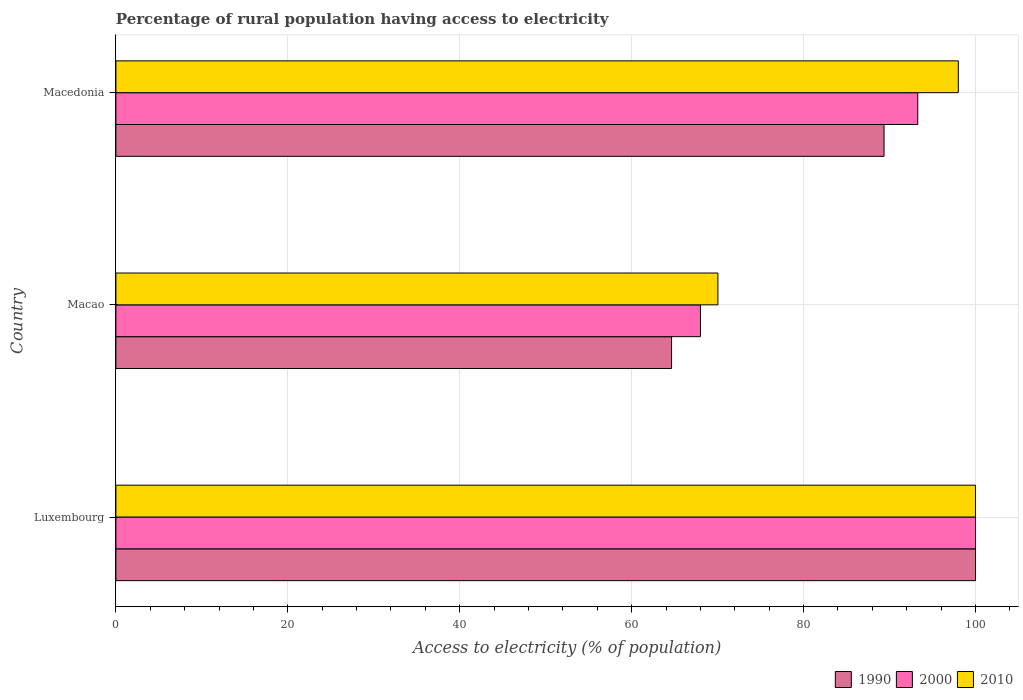How many groups of bars are there?
Make the answer very short. 3. Are the number of bars on each tick of the Y-axis equal?
Offer a very short reply. Yes. How many bars are there on the 1st tick from the top?
Your answer should be very brief. 3. How many bars are there on the 2nd tick from the bottom?
Make the answer very short. 3. What is the label of the 3rd group of bars from the top?
Make the answer very short. Luxembourg. What is the percentage of rural population having access to electricity in 1990 in Luxembourg?
Your response must be concise. 100. Across all countries, what is the maximum percentage of rural population having access to electricity in 1990?
Make the answer very short. 100. Across all countries, what is the minimum percentage of rural population having access to electricity in 1990?
Your answer should be very brief. 64.64. In which country was the percentage of rural population having access to electricity in 2000 maximum?
Keep it short and to the point. Luxembourg. In which country was the percentage of rural population having access to electricity in 2000 minimum?
Your response must be concise. Macao. What is the total percentage of rural population having access to electricity in 2010 in the graph?
Give a very brief answer. 268.03. What is the difference between the percentage of rural population having access to electricity in 1990 in Macao and that in Macedonia?
Your response must be concise. -24.72. What is the difference between the percentage of rural population having access to electricity in 2000 in Macao and the percentage of rural population having access to electricity in 1990 in Luxembourg?
Your answer should be compact. -32. What is the average percentage of rural population having access to electricity in 1990 per country?
Give a very brief answer. 84.67. What is the difference between the percentage of rural population having access to electricity in 1990 and percentage of rural population having access to electricity in 2010 in Macao?
Your answer should be very brief. -5.39. In how many countries, is the percentage of rural population having access to electricity in 2010 greater than 68 %?
Offer a very short reply. 3. What is the ratio of the percentage of rural population having access to electricity in 1990 in Macao to that in Macedonia?
Give a very brief answer. 0.72. Is the difference between the percentage of rural population having access to electricity in 1990 in Luxembourg and Macao greater than the difference between the percentage of rural population having access to electricity in 2010 in Luxembourg and Macao?
Your answer should be compact. Yes. What is the difference between the highest and the second highest percentage of rural population having access to electricity in 1990?
Your answer should be very brief. 10.64. What is the difference between the highest and the lowest percentage of rural population having access to electricity in 1990?
Provide a short and direct response. 35.36. What does the 1st bar from the top in Macedonia represents?
Provide a succinct answer. 2010. Are all the bars in the graph horizontal?
Your response must be concise. Yes. Are the values on the major ticks of X-axis written in scientific E-notation?
Give a very brief answer. No. Does the graph contain any zero values?
Offer a very short reply. No. Where does the legend appear in the graph?
Offer a very short reply. Bottom right. How many legend labels are there?
Provide a succinct answer. 3. What is the title of the graph?
Ensure brevity in your answer.  Percentage of rural population having access to electricity. Does "1964" appear as one of the legend labels in the graph?
Your answer should be compact. No. What is the label or title of the X-axis?
Ensure brevity in your answer.  Access to electricity (% of population). What is the label or title of the Y-axis?
Give a very brief answer. Country. What is the Access to electricity (% of population) of 2010 in Luxembourg?
Your answer should be very brief. 100. What is the Access to electricity (% of population) of 1990 in Macao?
Provide a succinct answer. 64.64. What is the Access to electricity (% of population) of 2000 in Macao?
Your response must be concise. 68. What is the Access to electricity (% of population) of 2010 in Macao?
Provide a short and direct response. 70.03. What is the Access to electricity (% of population) in 1990 in Macedonia?
Make the answer very short. 89.36. What is the Access to electricity (% of population) in 2000 in Macedonia?
Your answer should be compact. 93.28. Across all countries, what is the maximum Access to electricity (% of population) in 2000?
Offer a terse response. 100. Across all countries, what is the minimum Access to electricity (% of population) of 1990?
Keep it short and to the point. 64.64. Across all countries, what is the minimum Access to electricity (% of population) in 2010?
Provide a short and direct response. 70.03. What is the total Access to electricity (% of population) in 1990 in the graph?
Make the answer very short. 254. What is the total Access to electricity (% of population) of 2000 in the graph?
Your answer should be compact. 261.28. What is the total Access to electricity (% of population) of 2010 in the graph?
Your answer should be compact. 268.03. What is the difference between the Access to electricity (% of population) of 1990 in Luxembourg and that in Macao?
Give a very brief answer. 35.36. What is the difference between the Access to electricity (% of population) of 2010 in Luxembourg and that in Macao?
Provide a short and direct response. 29.97. What is the difference between the Access to electricity (% of population) of 1990 in Luxembourg and that in Macedonia?
Your response must be concise. 10.64. What is the difference between the Access to electricity (% of population) in 2000 in Luxembourg and that in Macedonia?
Ensure brevity in your answer.  6.72. What is the difference between the Access to electricity (% of population) of 1990 in Macao and that in Macedonia?
Provide a succinct answer. -24.72. What is the difference between the Access to electricity (% of population) in 2000 in Macao and that in Macedonia?
Offer a terse response. -25.28. What is the difference between the Access to electricity (% of population) of 2010 in Macao and that in Macedonia?
Keep it short and to the point. -27.97. What is the difference between the Access to electricity (% of population) of 1990 in Luxembourg and the Access to electricity (% of population) of 2000 in Macao?
Give a very brief answer. 32. What is the difference between the Access to electricity (% of population) in 1990 in Luxembourg and the Access to electricity (% of population) in 2010 in Macao?
Give a very brief answer. 29.97. What is the difference between the Access to electricity (% of population) of 2000 in Luxembourg and the Access to electricity (% of population) of 2010 in Macao?
Keep it short and to the point. 29.97. What is the difference between the Access to electricity (% of population) in 1990 in Luxembourg and the Access to electricity (% of population) in 2000 in Macedonia?
Your answer should be very brief. 6.72. What is the difference between the Access to electricity (% of population) of 2000 in Luxembourg and the Access to electricity (% of population) of 2010 in Macedonia?
Offer a very short reply. 2. What is the difference between the Access to electricity (% of population) in 1990 in Macao and the Access to electricity (% of population) in 2000 in Macedonia?
Make the answer very short. -28.64. What is the difference between the Access to electricity (% of population) in 1990 in Macao and the Access to electricity (% of population) in 2010 in Macedonia?
Your answer should be very brief. -33.36. What is the difference between the Access to electricity (% of population) of 2000 in Macao and the Access to electricity (% of population) of 2010 in Macedonia?
Ensure brevity in your answer.  -30. What is the average Access to electricity (% of population) of 1990 per country?
Ensure brevity in your answer.  84.67. What is the average Access to electricity (% of population) of 2000 per country?
Keep it short and to the point. 87.09. What is the average Access to electricity (% of population) in 2010 per country?
Offer a terse response. 89.34. What is the difference between the Access to electricity (% of population) in 1990 and Access to electricity (% of population) in 2010 in Luxembourg?
Provide a short and direct response. 0. What is the difference between the Access to electricity (% of population) in 2000 and Access to electricity (% of population) in 2010 in Luxembourg?
Your response must be concise. 0. What is the difference between the Access to electricity (% of population) of 1990 and Access to electricity (% of population) of 2000 in Macao?
Your answer should be very brief. -3.36. What is the difference between the Access to electricity (% of population) in 1990 and Access to electricity (% of population) in 2010 in Macao?
Your answer should be very brief. -5.39. What is the difference between the Access to electricity (% of population) in 2000 and Access to electricity (% of population) in 2010 in Macao?
Keep it short and to the point. -2.03. What is the difference between the Access to electricity (% of population) of 1990 and Access to electricity (% of population) of 2000 in Macedonia?
Provide a short and direct response. -3.92. What is the difference between the Access to electricity (% of population) of 1990 and Access to electricity (% of population) of 2010 in Macedonia?
Keep it short and to the point. -8.64. What is the difference between the Access to electricity (% of population) of 2000 and Access to electricity (% of population) of 2010 in Macedonia?
Your answer should be compact. -4.72. What is the ratio of the Access to electricity (% of population) in 1990 in Luxembourg to that in Macao?
Make the answer very short. 1.55. What is the ratio of the Access to electricity (% of population) of 2000 in Luxembourg to that in Macao?
Give a very brief answer. 1.47. What is the ratio of the Access to electricity (% of population) of 2010 in Luxembourg to that in Macao?
Offer a terse response. 1.43. What is the ratio of the Access to electricity (% of population) in 1990 in Luxembourg to that in Macedonia?
Provide a short and direct response. 1.12. What is the ratio of the Access to electricity (% of population) of 2000 in Luxembourg to that in Macedonia?
Your answer should be compact. 1.07. What is the ratio of the Access to electricity (% of population) in 2010 in Luxembourg to that in Macedonia?
Make the answer very short. 1.02. What is the ratio of the Access to electricity (% of population) of 1990 in Macao to that in Macedonia?
Your response must be concise. 0.72. What is the ratio of the Access to electricity (% of population) of 2000 in Macao to that in Macedonia?
Offer a terse response. 0.73. What is the ratio of the Access to electricity (% of population) in 2010 in Macao to that in Macedonia?
Make the answer very short. 0.71. What is the difference between the highest and the second highest Access to electricity (% of population) of 1990?
Provide a succinct answer. 10.64. What is the difference between the highest and the second highest Access to electricity (% of population) in 2000?
Make the answer very short. 6.72. What is the difference between the highest and the lowest Access to electricity (% of population) of 1990?
Make the answer very short. 35.36. What is the difference between the highest and the lowest Access to electricity (% of population) in 2000?
Provide a short and direct response. 32. What is the difference between the highest and the lowest Access to electricity (% of population) in 2010?
Keep it short and to the point. 29.97. 